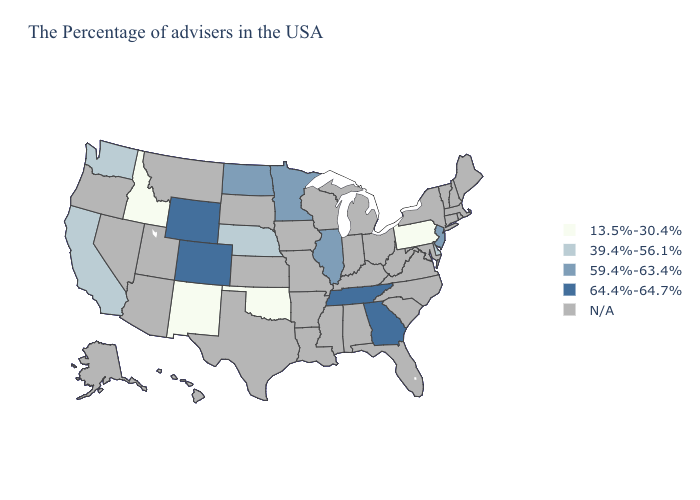Name the states that have a value in the range 64.4%-64.7%?
Keep it brief. Georgia, Tennessee, Wyoming, Colorado. Among the states that border Missouri , which have the lowest value?
Write a very short answer. Oklahoma. Does Idaho have the highest value in the West?
Be succinct. No. Does the first symbol in the legend represent the smallest category?
Write a very short answer. Yes. Does the first symbol in the legend represent the smallest category?
Keep it brief. Yes. Does North Dakota have the highest value in the USA?
Answer briefly. No. Among the states that border Missouri , does Oklahoma have the lowest value?
Give a very brief answer. Yes. Which states have the lowest value in the MidWest?
Be succinct. Nebraska. Name the states that have a value in the range N/A?
Be succinct. Maine, Massachusetts, Rhode Island, New Hampshire, Vermont, Connecticut, New York, Maryland, Virginia, North Carolina, South Carolina, West Virginia, Ohio, Florida, Michigan, Kentucky, Indiana, Alabama, Wisconsin, Mississippi, Louisiana, Missouri, Arkansas, Iowa, Kansas, Texas, South Dakota, Utah, Montana, Arizona, Nevada, Oregon, Alaska, Hawaii. How many symbols are there in the legend?
Be succinct. 5. Does the map have missing data?
Answer briefly. Yes. Among the states that border Kansas , which have the lowest value?
Short answer required. Oklahoma. What is the value of Wyoming?
Answer briefly. 64.4%-64.7%. 